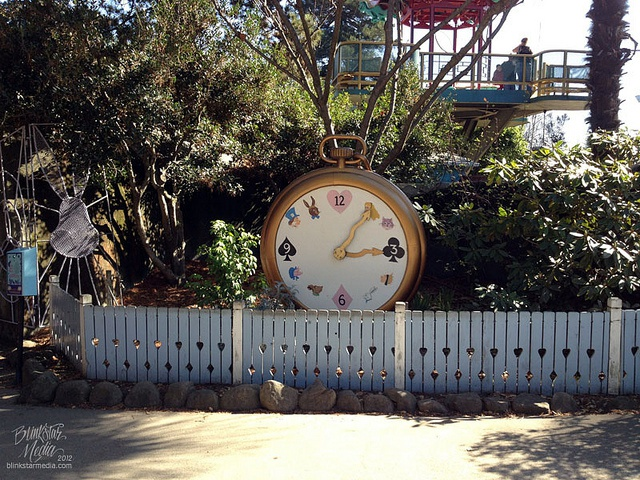Describe the objects in this image and their specific colors. I can see clock in white, darkgray, gray, black, and maroon tones, people in white, navy, darkblue, gray, and black tones, people in white, gray, navy, darkblue, and black tones, and people in white, gray, maroon, and purple tones in this image. 